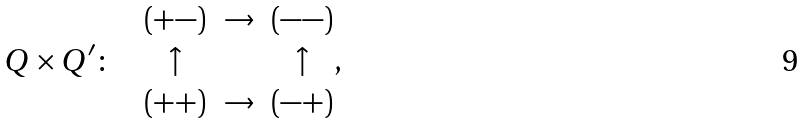<formula> <loc_0><loc_0><loc_500><loc_500>Q \times Q ^ { \prime } \colon \quad \begin{matrix} ( + - ) & \rightarrow & ( - - ) \\ \uparrow & & \uparrow \\ ( + + ) & \rightarrow & ( - + ) \end{matrix} ,</formula> 